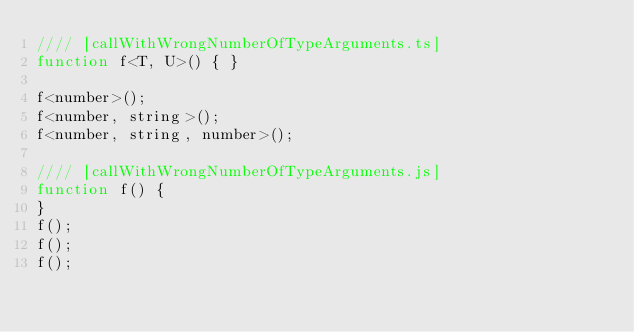<code> <loc_0><loc_0><loc_500><loc_500><_JavaScript_>//// [callWithWrongNumberOfTypeArguments.ts]
function f<T, U>() { }

f<number>();
f<number, string>();
f<number, string, number>();

//// [callWithWrongNumberOfTypeArguments.js]
function f() {
}
f();
f();
f();
</code> 